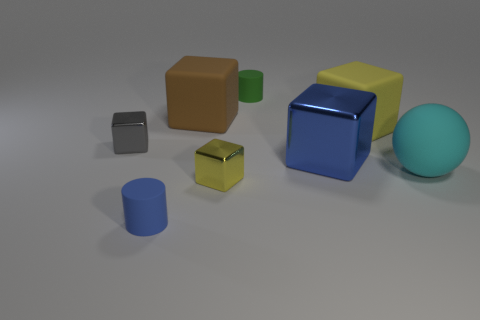Subtract all yellow rubber cubes. How many cubes are left? 4 Subtract 2 cubes. How many cubes are left? 3 Subtract all brown cubes. How many cubes are left? 4 Subtract all brown blocks. Subtract all purple spheres. How many blocks are left? 4 Add 1 cyan rubber things. How many objects exist? 9 Subtract all cylinders. How many objects are left? 6 Subtract 0 purple blocks. How many objects are left? 8 Subtract all tiny red matte things. Subtract all large balls. How many objects are left? 7 Add 8 small cylinders. How many small cylinders are left? 10 Add 4 tiny brown cubes. How many tiny brown cubes exist? 4 